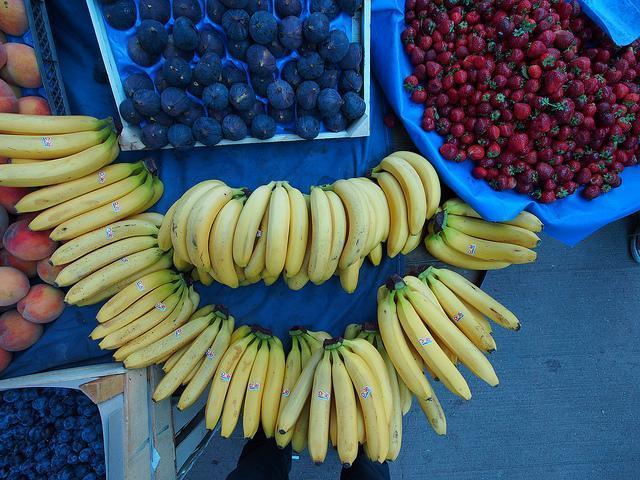How many different food products are there?
Give a very brief answer. 5. How many bananas are in the picture?
Give a very brief answer. 12. How many sheep are there?
Give a very brief answer. 0. 